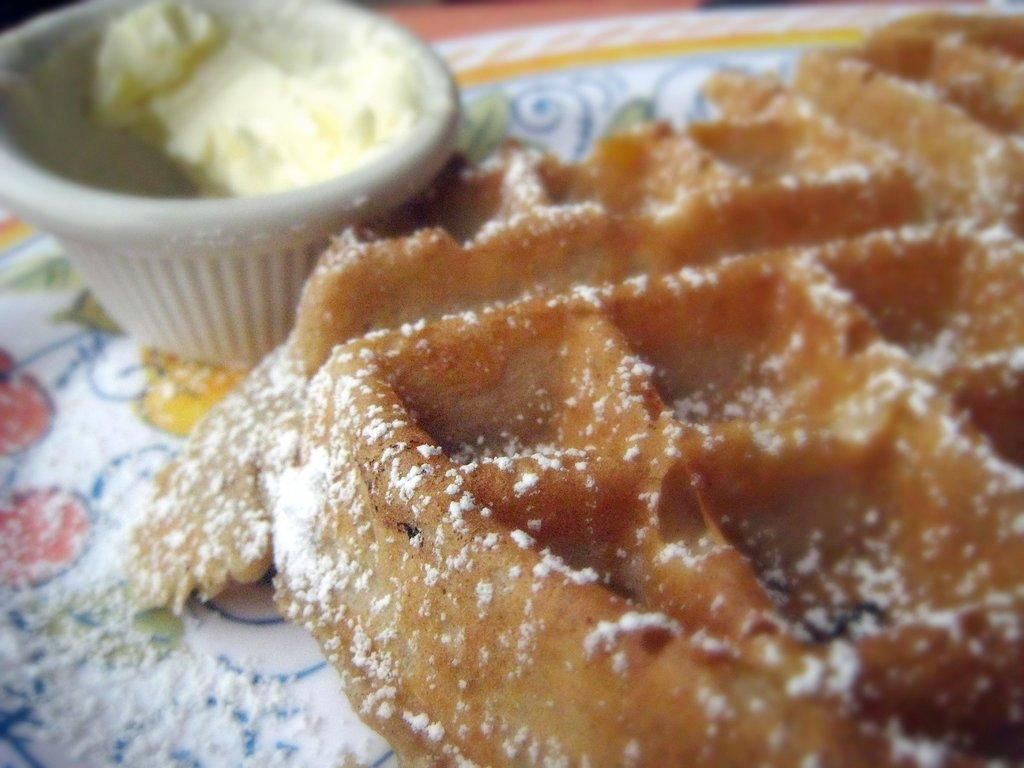What is the main food item in the image? There is a waffle in the image. What is served on top of the waffle? Cream is served on the waffle. What additional topping is present on the waffle? Sugar powder is sprinkled on the waffle. On what is the waffle placed? The waffle is on a plate. Can you see any worms crawling on the waffle in the image? No, there are no worms present in the image. 